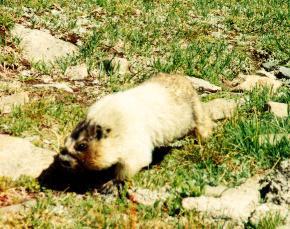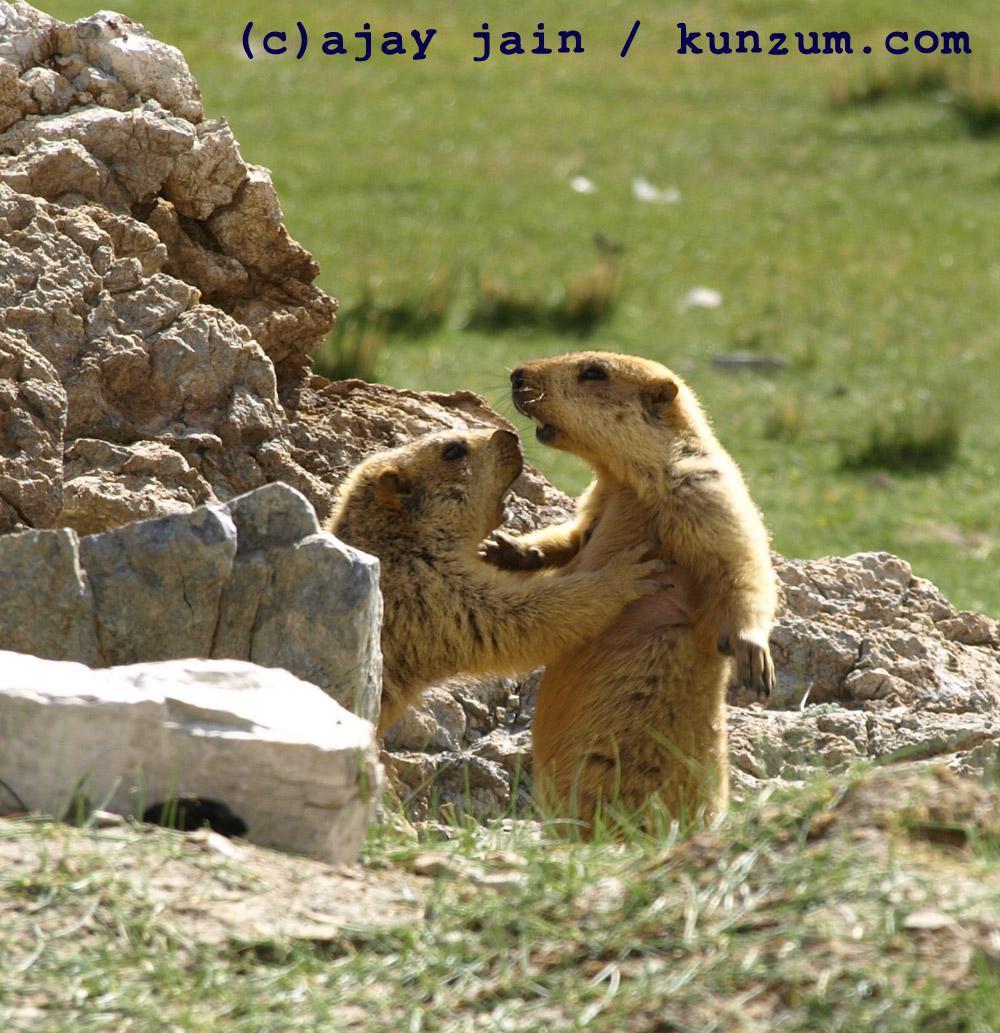The first image is the image on the left, the second image is the image on the right. Given the left and right images, does the statement "There are at least three rodents." hold true? Answer yes or no. Yes. The first image is the image on the left, the second image is the image on the right. Considering the images on both sides, is "At least two animals are very close to each other." valid? Answer yes or no. Yes. 